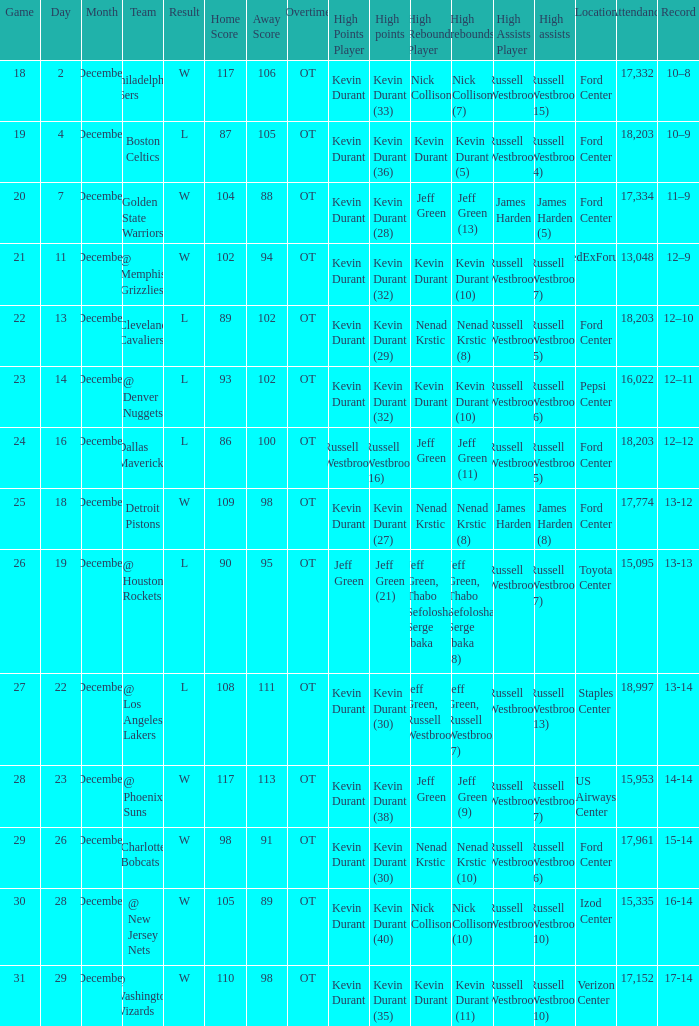What is the score for the date of December 7? W 104–88 (OT). 